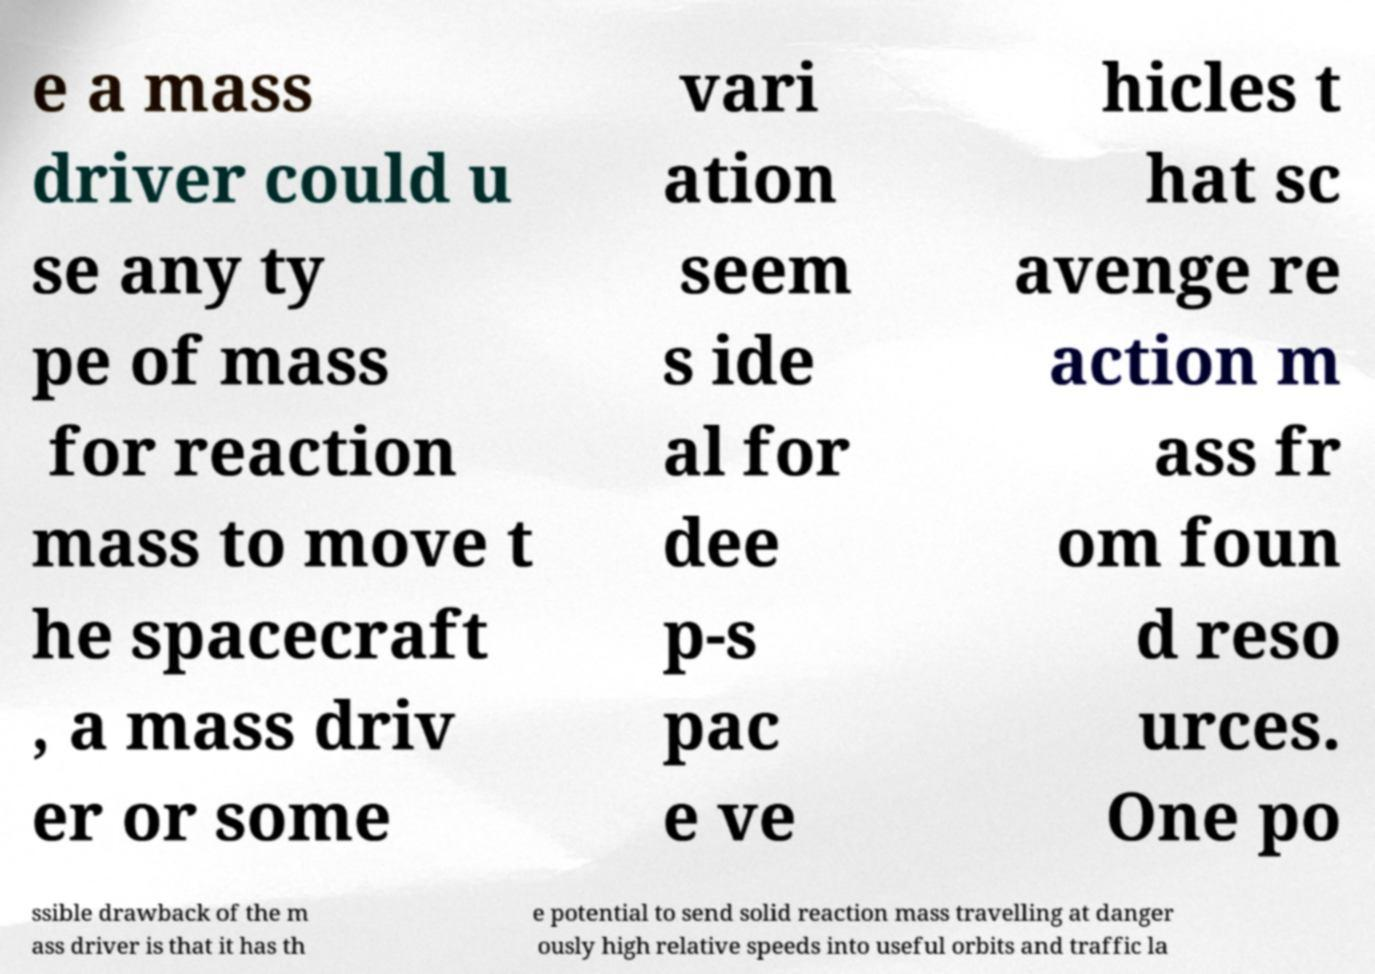Could you extract and type out the text from this image? e a mass driver could u se any ty pe of mass for reaction mass to move t he spacecraft , a mass driv er or some vari ation seem s ide al for dee p-s pac e ve hicles t hat sc avenge re action m ass fr om foun d reso urces. One po ssible drawback of the m ass driver is that it has th e potential to send solid reaction mass travelling at danger ously high relative speeds into useful orbits and traffic la 